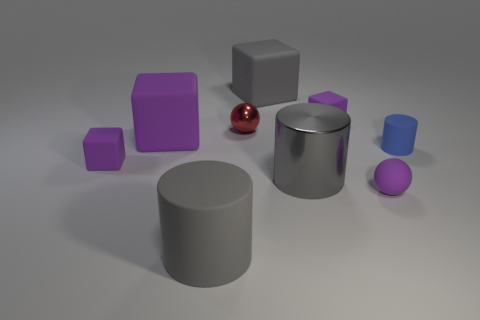Subtract all rubber cylinders. How many cylinders are left? 1 Subtract all gray cylinders. How many purple cubes are left? 3 Subtract all gray cubes. How many cubes are left? 3 Subtract 1 cylinders. How many cylinders are left? 2 Add 1 tiny red matte objects. How many objects exist? 10 Subtract all blue blocks. Subtract all purple cylinders. How many blocks are left? 4 Subtract all balls. How many objects are left? 7 Add 1 tiny matte cubes. How many tiny matte cubes exist? 3 Subtract 0 yellow cylinders. How many objects are left? 9 Subtract all green matte cubes. Subtract all big gray things. How many objects are left? 6 